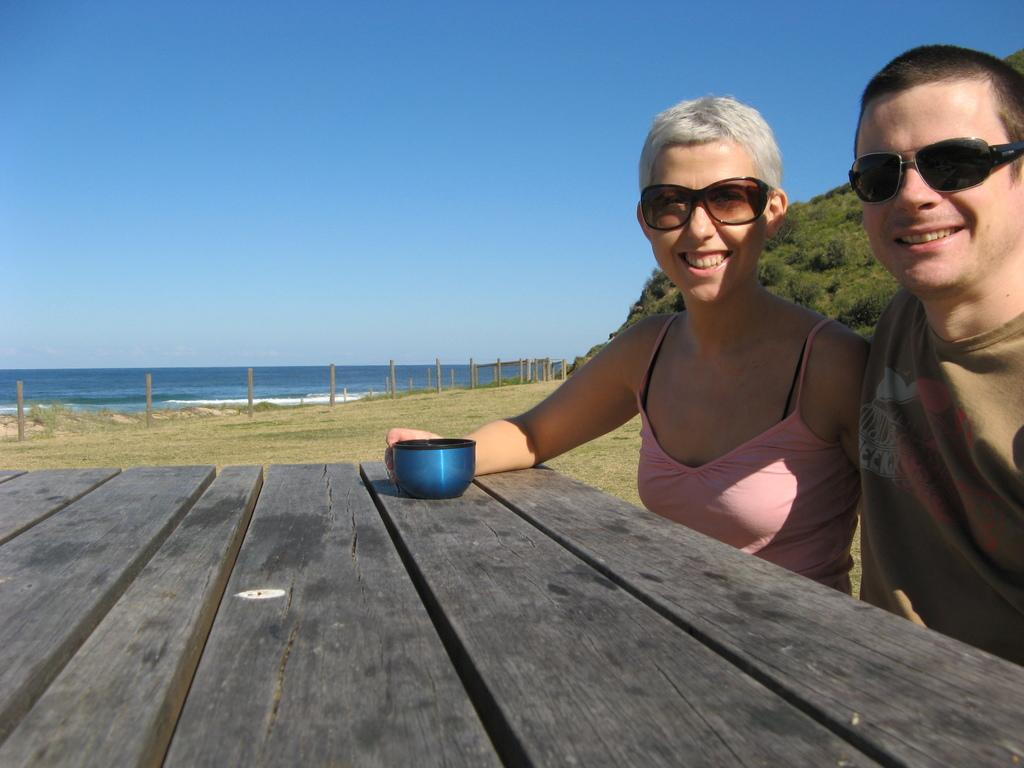How many people are in the image? There are two persons on the right side of the image. What is in front of the persons? There is a table in front of the persons. What is placed on the table? A cup is placed on the table. What can be seen behind the persons? There are trees behind the persons. What is visible in the background? There is water visible in the background. Are there any birds swimming in the water in the background? There are no birds or swimming activity visible in the image; it only shows two persons, a table, a cup, trees, and water in the background. 